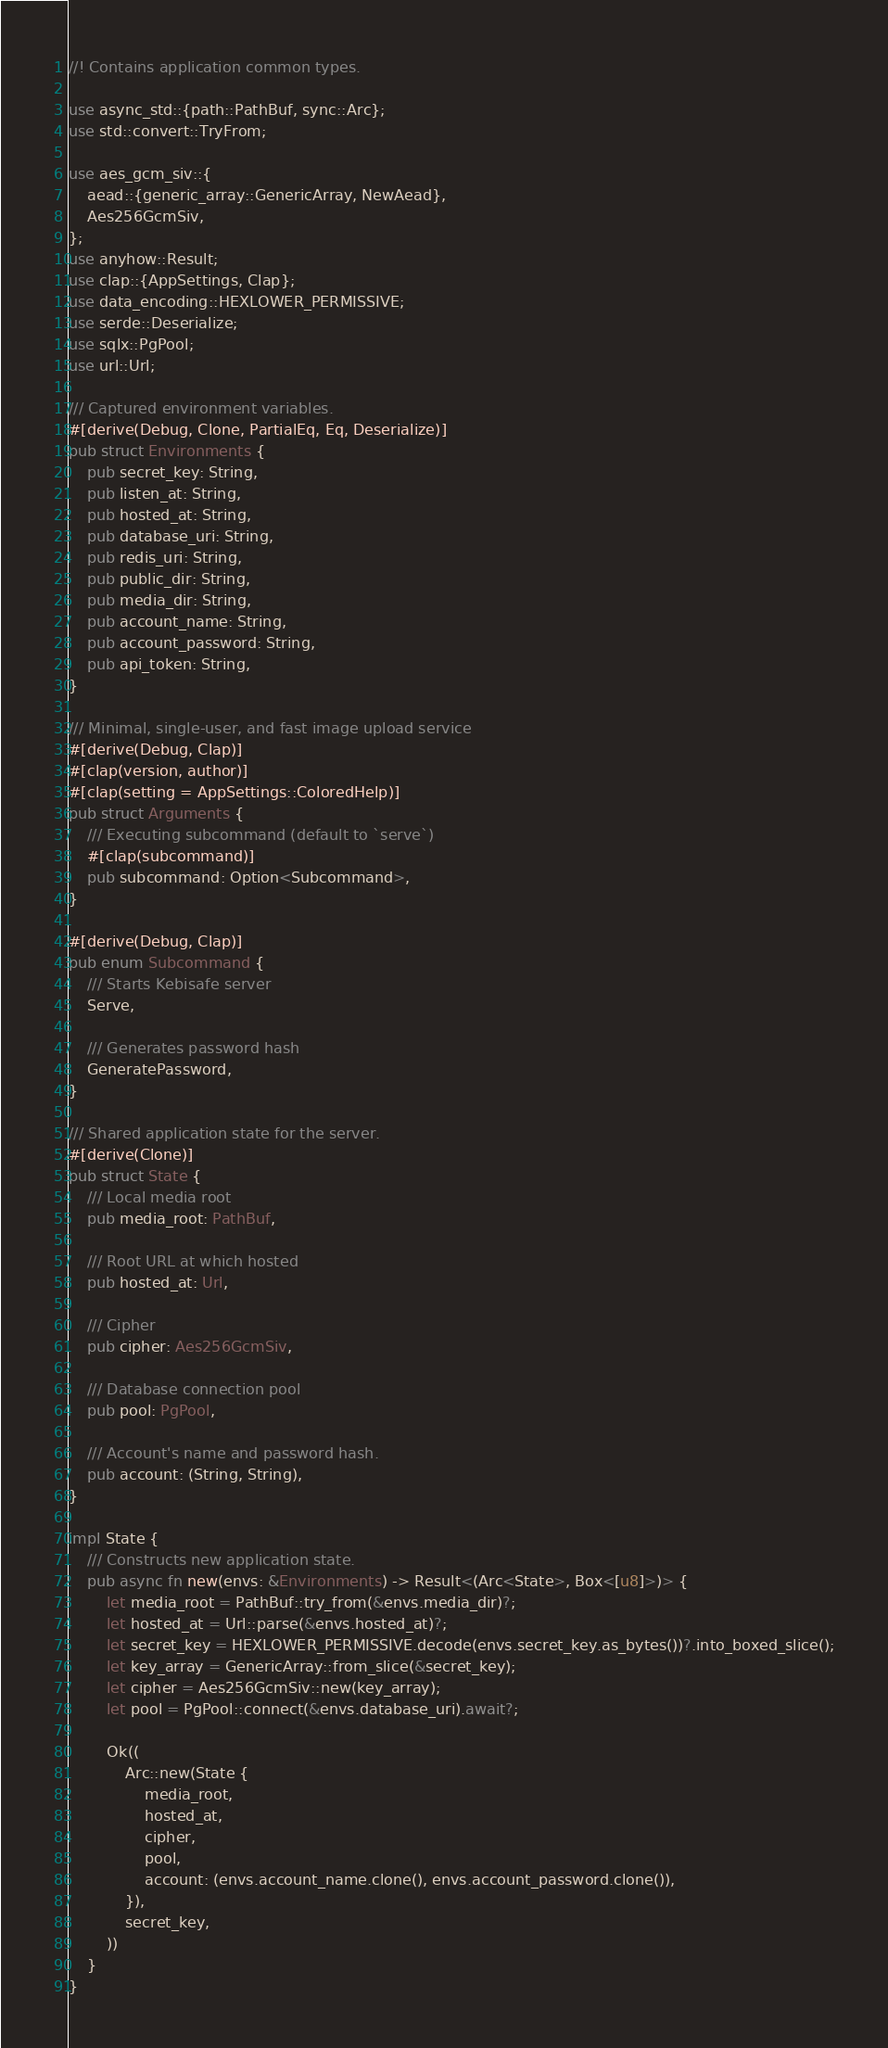Convert code to text. <code><loc_0><loc_0><loc_500><loc_500><_Rust_>//! Contains application common types.

use async_std::{path::PathBuf, sync::Arc};
use std::convert::TryFrom;

use aes_gcm_siv::{
    aead::{generic_array::GenericArray, NewAead},
    Aes256GcmSiv,
};
use anyhow::Result;
use clap::{AppSettings, Clap};
use data_encoding::HEXLOWER_PERMISSIVE;
use serde::Deserialize;
use sqlx::PgPool;
use url::Url;

/// Captured environment variables.
#[derive(Debug, Clone, PartialEq, Eq, Deserialize)]
pub struct Environments {
    pub secret_key: String,
    pub listen_at: String,
    pub hosted_at: String,
    pub database_uri: String,
    pub redis_uri: String,
    pub public_dir: String,
    pub media_dir: String,
    pub account_name: String,
    pub account_password: String,
    pub api_token: String,
}

/// Minimal, single-user, and fast image upload service
#[derive(Debug, Clap)]
#[clap(version, author)]
#[clap(setting = AppSettings::ColoredHelp)]
pub struct Arguments {
    /// Executing subcommand (default to `serve`)
    #[clap(subcommand)]
    pub subcommand: Option<Subcommand>,
}

#[derive(Debug, Clap)]
pub enum Subcommand {
    /// Starts Kebisafe server
    Serve,

    /// Generates password hash
    GeneratePassword,
}

/// Shared application state for the server.
#[derive(Clone)]
pub struct State {
    /// Local media root
    pub media_root: PathBuf,

    /// Root URL at which hosted
    pub hosted_at: Url,

    /// Cipher
    pub cipher: Aes256GcmSiv,

    /// Database connection pool
    pub pool: PgPool,

    /// Account's name and password hash.
    pub account: (String, String),
}

impl State {
    /// Constructs new application state.
    pub async fn new(envs: &Environments) -> Result<(Arc<State>, Box<[u8]>)> {
        let media_root = PathBuf::try_from(&envs.media_dir)?;
        let hosted_at = Url::parse(&envs.hosted_at)?;
        let secret_key = HEXLOWER_PERMISSIVE.decode(envs.secret_key.as_bytes())?.into_boxed_slice();
        let key_array = GenericArray::from_slice(&secret_key);
        let cipher = Aes256GcmSiv::new(key_array);
        let pool = PgPool::connect(&envs.database_uri).await?;

        Ok((
            Arc::new(State {
                media_root,
                hosted_at,
                cipher,
                pool,
                account: (envs.account_name.clone(), envs.account_password.clone()),
            }),
            secret_key,
        ))
    }
}
</code> 